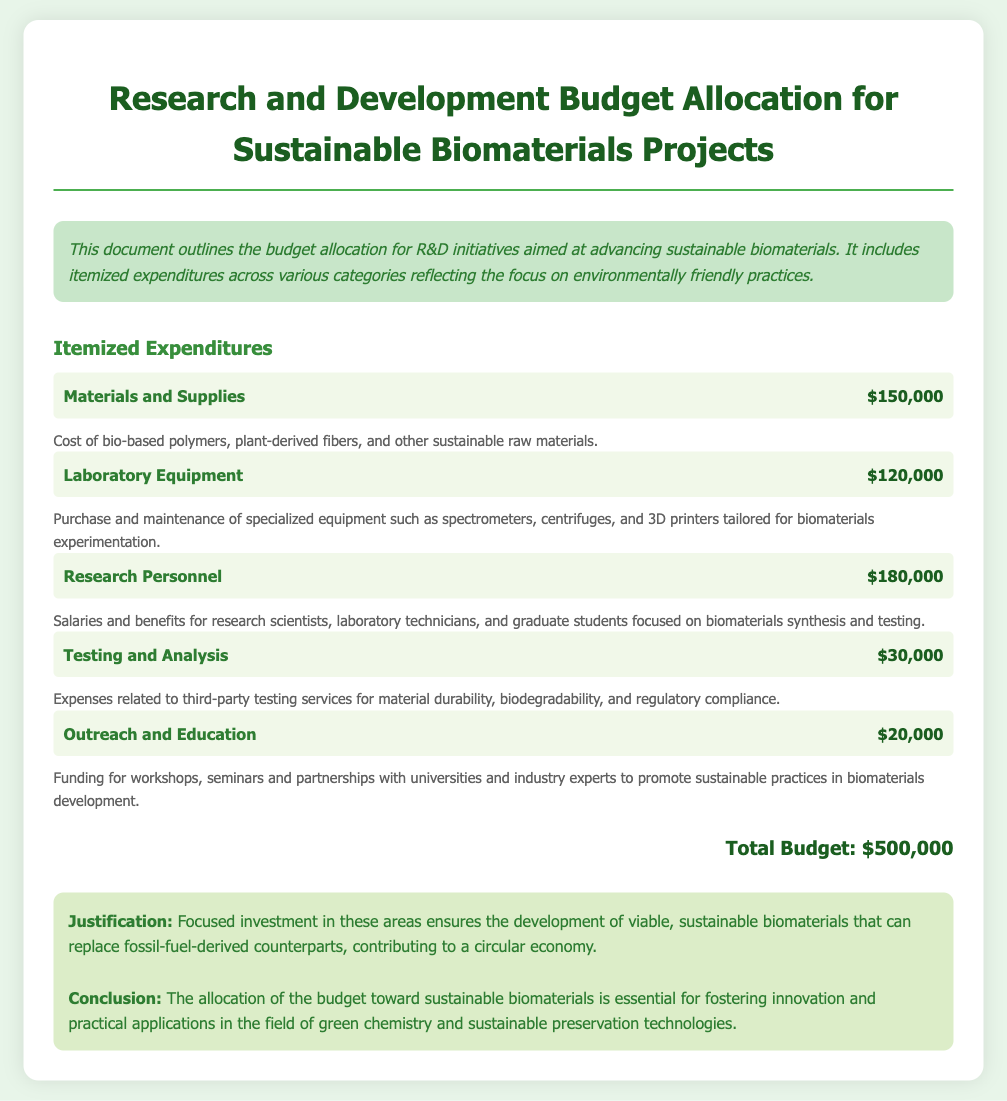What is the total budget allocated? The total budget is given at the end of the itemized expenditures section, which is the cumulative amount of various expenditures.
Answer: $500,000 What is the expenditure for laboratory equipment? The specific expenditure amount for laboratory equipment is listed under itemized expenditures.
Answer: $120,000 How much is allocated for outreach and education? The amount designated for outreach and education is among the listed itemized expenditures.
Answer: $20,000 What category has the highest budget allocation? To find the category with the highest allocation, compare the expenditures across all categories listed in the document.
Answer: Research Personnel What is described in the justification section? The justification section explains the reasoning behind the budget allocation for sustainable biomaterials projects in relation to environmental impact.
Answer: Viable, sustainable biomaterials How much is allocated for testing and analysis? This amount is part of the itemized expenditures and can be found in the relevant section.
Answer: $30,000 What type of report is this document categorized as? The document outlines the financial planning related to research initiatives within a specific field, which aligns with a particular category of documentation.
Answer: Financial report What materials are part of the expenditures for materials and supplies? The description below the expenditures lists specific materials being utilized for the projects.
Answer: Bio-based polymers, plant-derived fibers How many categories are included in the itemized expenditures? To find the total categories, count each distinct expenditure category listed in the document.
Answer: Five 